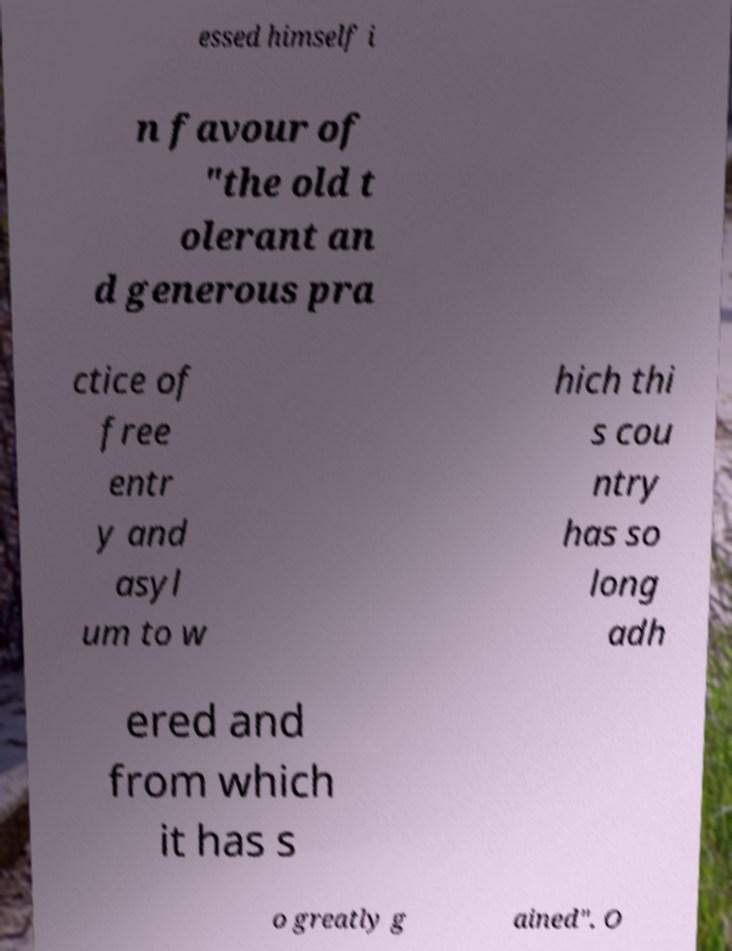Can you read and provide the text displayed in the image?This photo seems to have some interesting text. Can you extract and type it out for me? essed himself i n favour of "the old t olerant an d generous pra ctice of free entr y and asyl um to w hich thi s cou ntry has so long adh ered and from which it has s o greatly g ained". O 